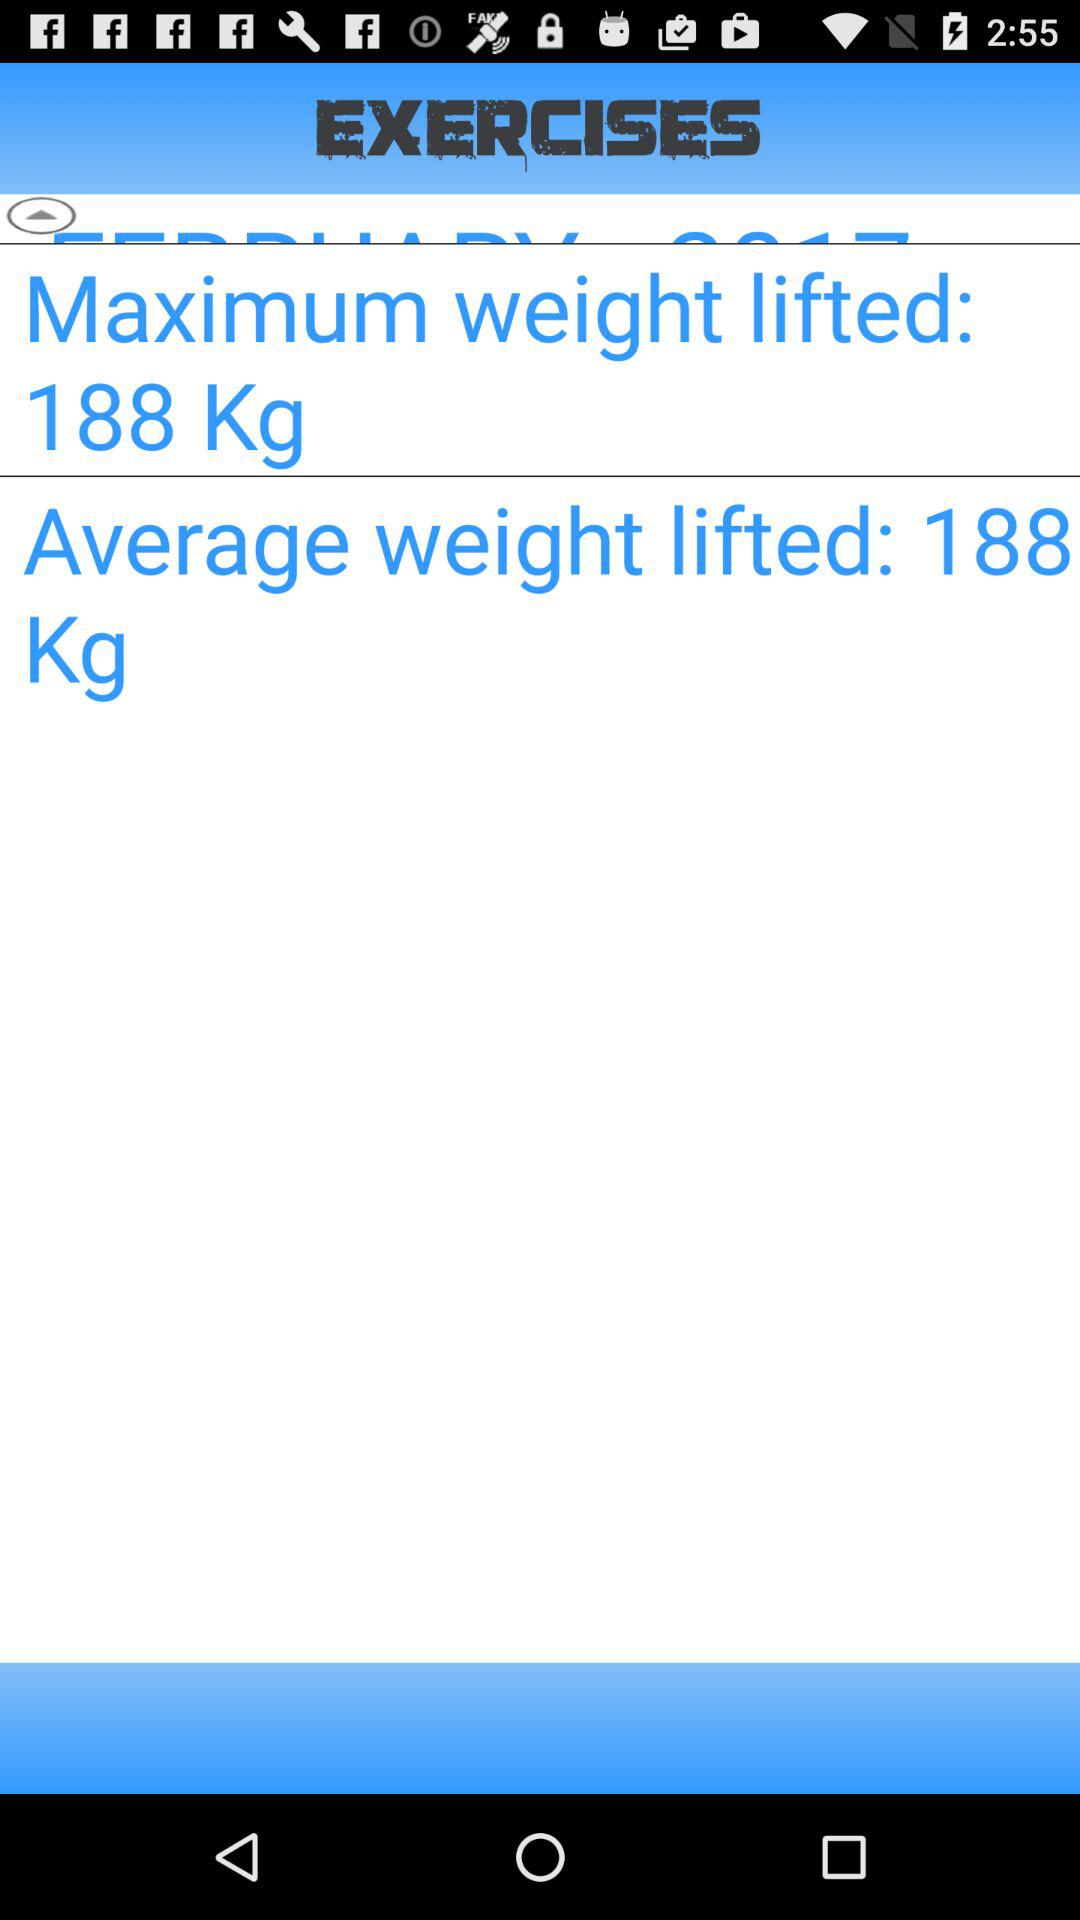What is the difference between the average and maximum weight lifted?
Answer the question using a single word or phrase. 0 Kg 